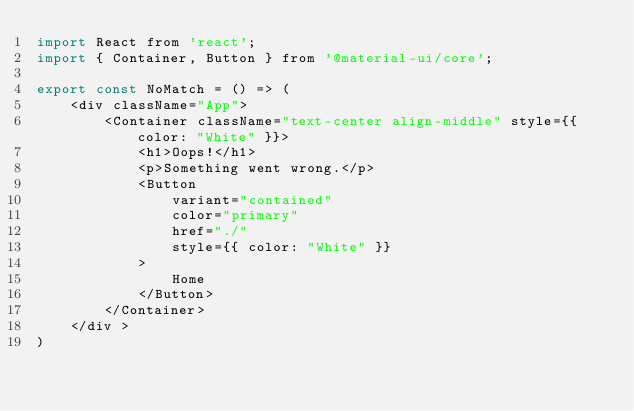<code> <loc_0><loc_0><loc_500><loc_500><_JavaScript_>import React from 'react';
import { Container, Button } from '@material-ui/core';

export const NoMatch = () => (
    <div className="App">
        <Container className="text-center align-middle" style={{ color: "White" }}>
            <h1>Oops!</h1>
            <p>Something went wrong.</p>
            <Button
                variant="contained"
                color="primary"
                href="./"
                style={{ color: "White" }}
            >
                Home
            </Button>
        </Container>
    </div >
)</code> 